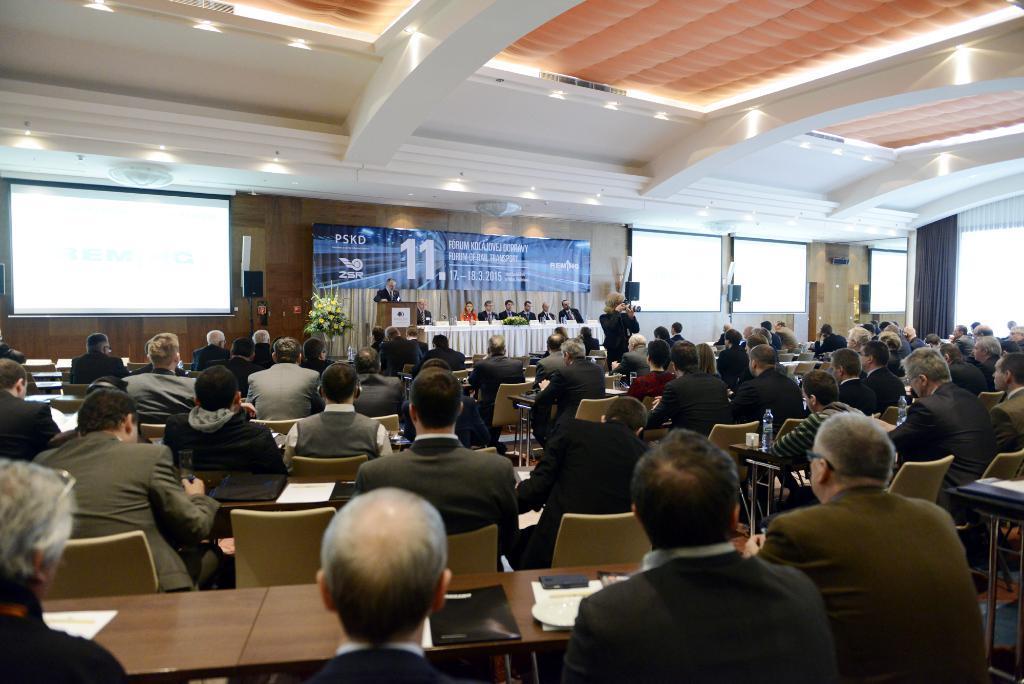In one or two sentences, can you explain what this image depicts? In this image I can see group of people sitting. In the background I can see the person standing in front of the podium and I can see the other person holding the camera, few plants in green color, projection screens and I can also see the banner in blue color and few curtains. 